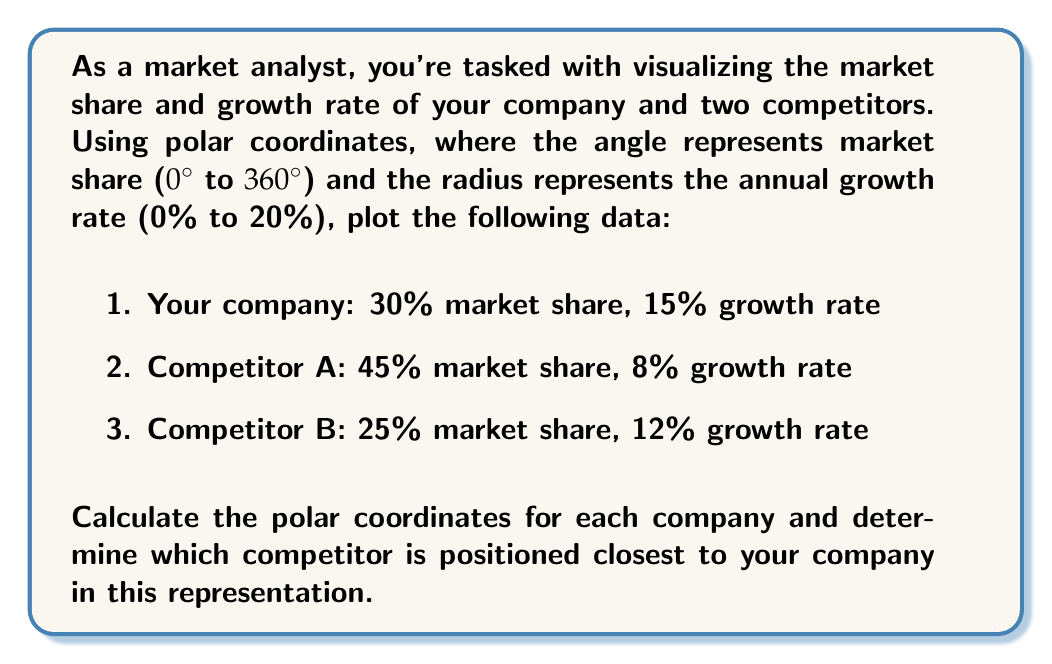Can you answer this question? To solve this problem, we need to convert the given percentages into polar coordinates and then calculate the distance between points.

1. Convert market share percentages to angles:
   - Your company: 30% of 360° = 108°
   - Competitor A: 45% of 360° = 162°
   - Competitor B: 25% of 360° = 90°

2. Use growth rates directly as radii (since they're already in the 0-20 range).

3. Polar coordinates for each company:
   - Your company: $(15, 108°)$
   - Competitor A: $(8, 162°)$
   - Competitor B: $(12, 90°)$

4. To find the closest competitor, we need to calculate the distance between points in polar coordinates. The formula for distance $d$ between two points $(r_1, \theta_1)$ and $(r_2, \theta_2)$ is:

   $$d = \sqrt{r_1^2 + r_2^2 - 2r_1r_2\cos(\theta_1 - \theta_2)}$$

5. Calculate distances:
   - Distance to Competitor A:
     $$d_A = \sqrt{15^2 + 8^2 - 2(15)(8)\cos(108° - 162°)}$$
     $$d_A = \sqrt{225 + 64 - 240\cos(-54°)} \approx 13.45$$

   - Distance to Competitor B:
     $$d_B = \sqrt{15^2 + 12^2 - 2(15)(12)\cos(108° - 90°)}$$
     $$d_B = \sqrt{225 + 144 - 360\cos(18°)} \approx 3.78$$

6. Competitor B has the smaller distance (3.78 vs 13.45), so it is positioned closest to your company in this representation.
Answer: Competitor B is positioned closest to your company with a distance of approximately 3.78 units in the polar coordinate representation. 